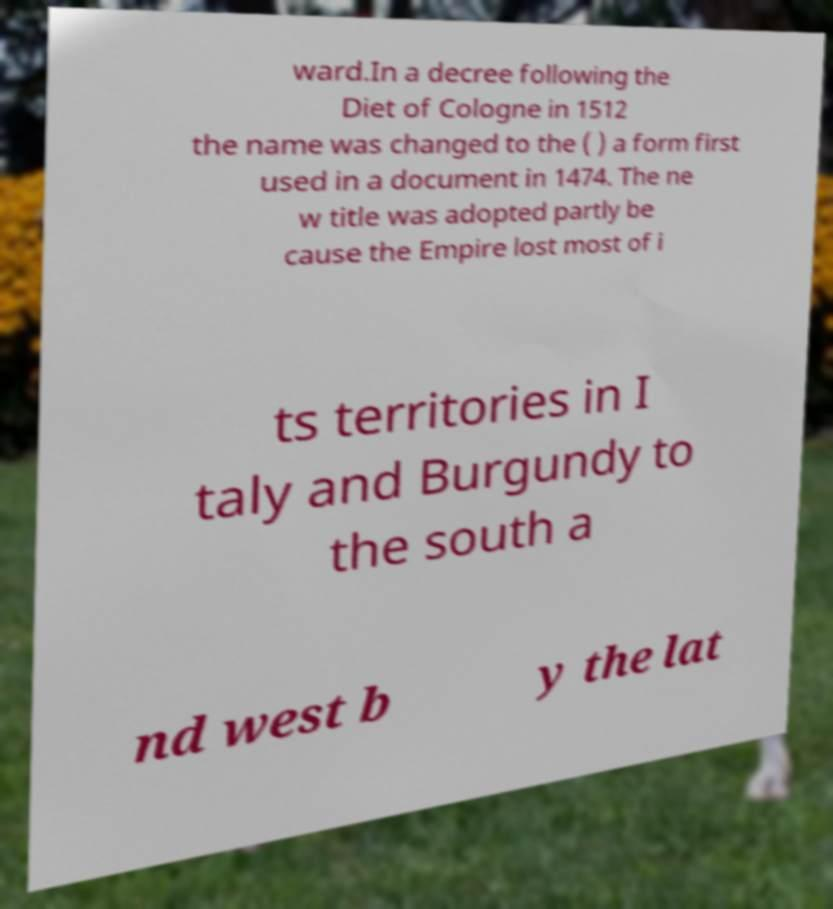Can you read and provide the text displayed in the image?This photo seems to have some interesting text. Can you extract and type it out for me? ward.In a decree following the Diet of Cologne in 1512 the name was changed to the ( ) a form first used in a document in 1474. The ne w title was adopted partly be cause the Empire lost most of i ts territories in I taly and Burgundy to the south a nd west b y the lat 